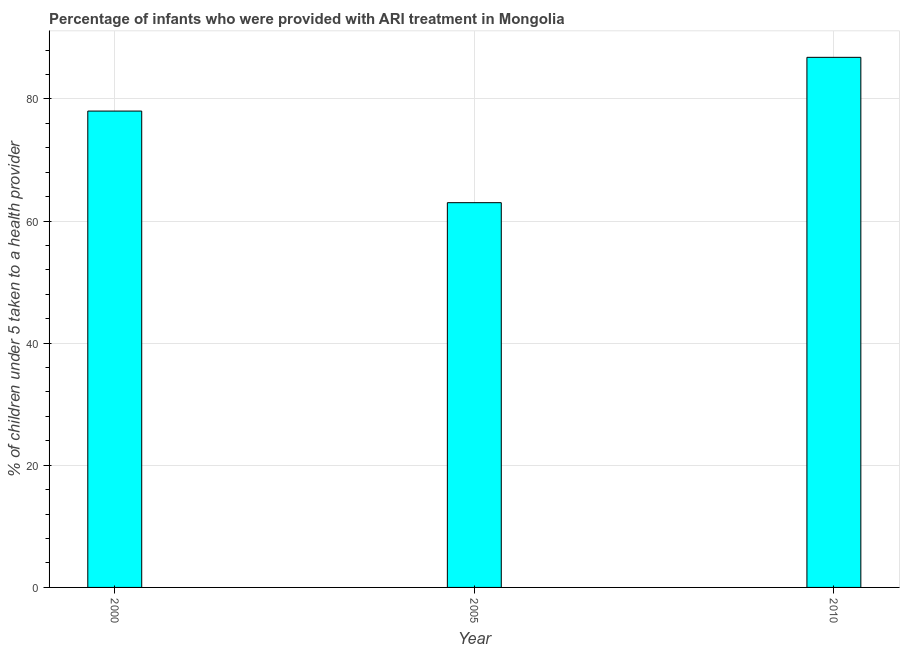Does the graph contain any zero values?
Make the answer very short. No. Does the graph contain grids?
Ensure brevity in your answer.  Yes. What is the title of the graph?
Make the answer very short. Percentage of infants who were provided with ARI treatment in Mongolia. What is the label or title of the Y-axis?
Provide a succinct answer. % of children under 5 taken to a health provider. What is the percentage of children who were provided with ari treatment in 2005?
Your answer should be very brief. 63. Across all years, what is the maximum percentage of children who were provided with ari treatment?
Your answer should be very brief. 86.8. Across all years, what is the minimum percentage of children who were provided with ari treatment?
Your response must be concise. 63. In which year was the percentage of children who were provided with ari treatment maximum?
Provide a short and direct response. 2010. In which year was the percentage of children who were provided with ari treatment minimum?
Offer a very short reply. 2005. What is the sum of the percentage of children who were provided with ari treatment?
Offer a terse response. 227.8. What is the average percentage of children who were provided with ari treatment per year?
Give a very brief answer. 75.93. What is the median percentage of children who were provided with ari treatment?
Provide a succinct answer. 78. In how many years, is the percentage of children who were provided with ari treatment greater than 72 %?
Give a very brief answer. 2. Do a majority of the years between 2000 and 2005 (inclusive) have percentage of children who were provided with ari treatment greater than 72 %?
Give a very brief answer. No. What is the ratio of the percentage of children who were provided with ari treatment in 2000 to that in 2010?
Offer a terse response. 0.9. Is the percentage of children who were provided with ari treatment in 2005 less than that in 2010?
Ensure brevity in your answer.  Yes. What is the difference between the highest and the second highest percentage of children who were provided with ari treatment?
Provide a short and direct response. 8.8. What is the difference between the highest and the lowest percentage of children who were provided with ari treatment?
Offer a terse response. 23.8. In how many years, is the percentage of children who were provided with ari treatment greater than the average percentage of children who were provided with ari treatment taken over all years?
Give a very brief answer. 2. How many years are there in the graph?
Give a very brief answer. 3. What is the difference between two consecutive major ticks on the Y-axis?
Offer a very short reply. 20. What is the % of children under 5 taken to a health provider in 2000?
Your answer should be compact. 78. What is the % of children under 5 taken to a health provider in 2010?
Offer a very short reply. 86.8. What is the difference between the % of children under 5 taken to a health provider in 2005 and 2010?
Provide a succinct answer. -23.8. What is the ratio of the % of children under 5 taken to a health provider in 2000 to that in 2005?
Your answer should be very brief. 1.24. What is the ratio of the % of children under 5 taken to a health provider in 2000 to that in 2010?
Make the answer very short. 0.9. What is the ratio of the % of children under 5 taken to a health provider in 2005 to that in 2010?
Provide a succinct answer. 0.73. 